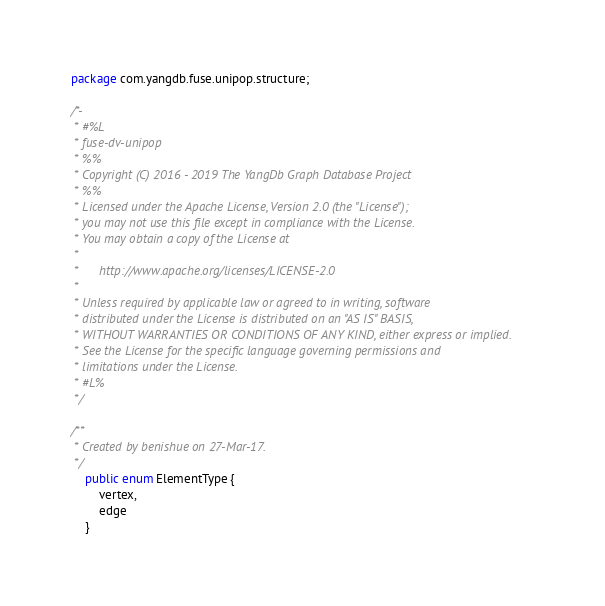Convert code to text. <code><loc_0><loc_0><loc_500><loc_500><_Java_>package com.yangdb.fuse.unipop.structure;

/*-
 * #%L
 * fuse-dv-unipop
 * %%
 * Copyright (C) 2016 - 2019 The YangDb Graph Database Project
 * %%
 * Licensed under the Apache License, Version 2.0 (the "License");
 * you may not use this file except in compliance with the License.
 * You may obtain a copy of the License at
 * 
 *      http://www.apache.org/licenses/LICENSE-2.0
 * 
 * Unless required by applicable law or agreed to in writing, software
 * distributed under the License is distributed on an "AS IS" BASIS,
 * WITHOUT WARRANTIES OR CONDITIONS OF ANY KIND, either express or implied.
 * See the License for the specific language governing permissions and
 * limitations under the License.
 * #L%
 */

/**
 * Created by benishue on 27-Mar-17.
 */
    public enum ElementType {
        vertex,
        edge
    }

</code> 